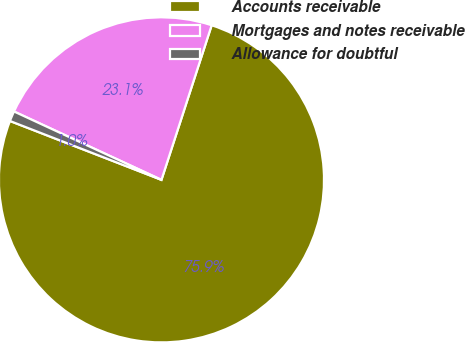<chart> <loc_0><loc_0><loc_500><loc_500><pie_chart><fcel>Accounts receivable<fcel>Mortgages and notes receivable<fcel>Allowance for doubtful<nl><fcel>75.9%<fcel>23.09%<fcel>1.01%<nl></chart> 